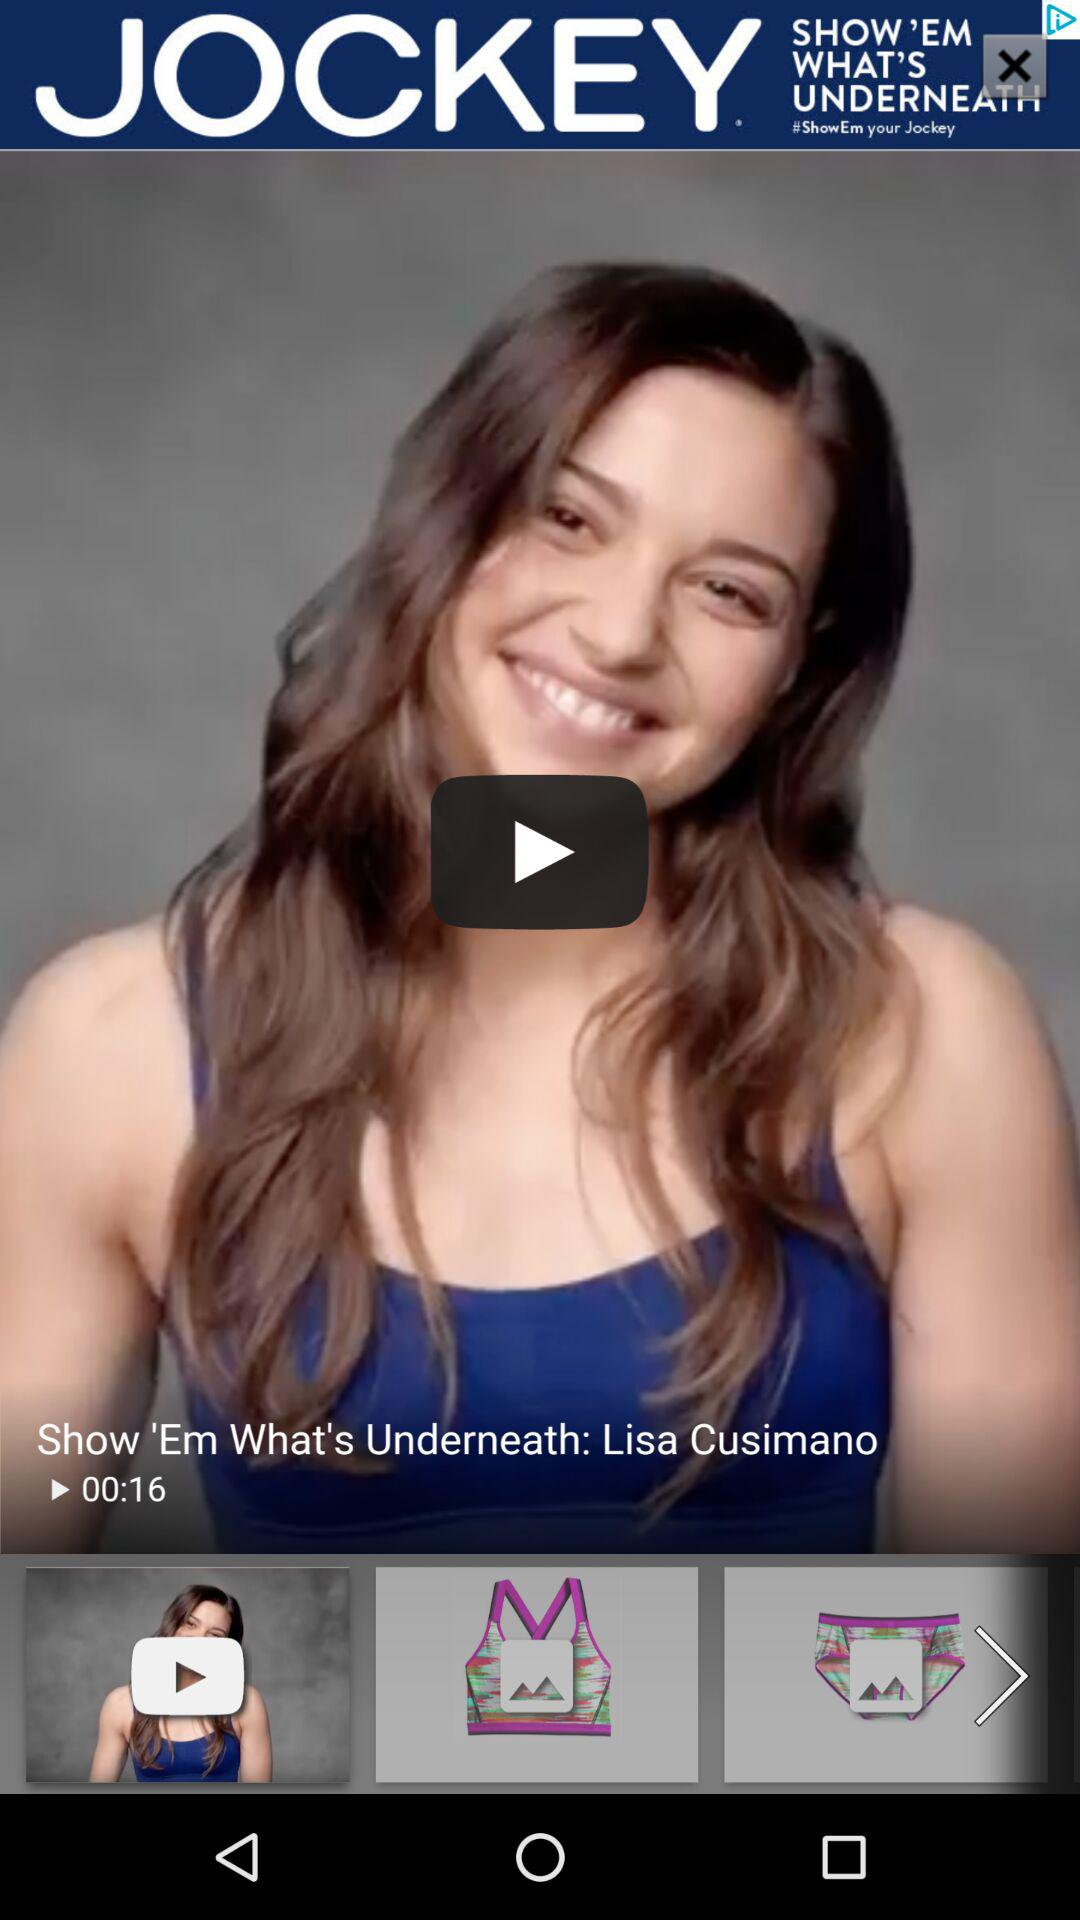How many seconds long is the video?
Answer the question using a single word or phrase. 16 